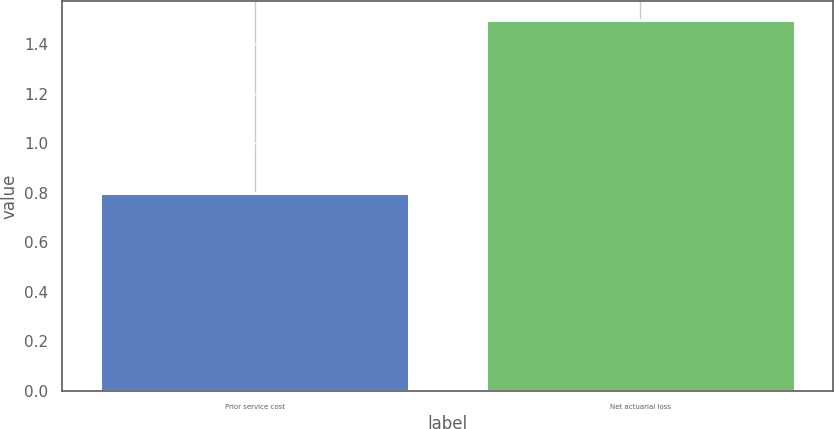<chart> <loc_0><loc_0><loc_500><loc_500><bar_chart><fcel>Prior service cost<fcel>Net actuarial loss<nl><fcel>0.8<fcel>1.5<nl></chart> 